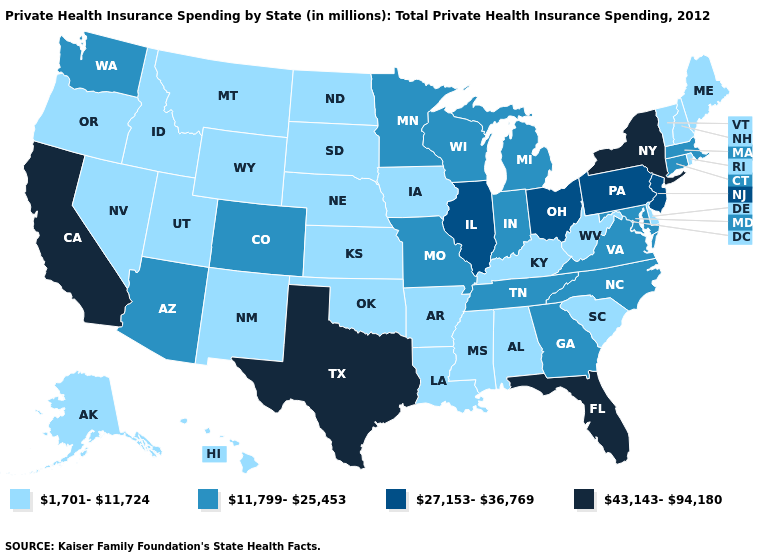Name the states that have a value in the range 1,701-11,724?
Quick response, please. Alabama, Alaska, Arkansas, Delaware, Hawaii, Idaho, Iowa, Kansas, Kentucky, Louisiana, Maine, Mississippi, Montana, Nebraska, Nevada, New Hampshire, New Mexico, North Dakota, Oklahoma, Oregon, Rhode Island, South Carolina, South Dakota, Utah, Vermont, West Virginia, Wyoming. What is the value of North Carolina?
Be succinct. 11,799-25,453. Name the states that have a value in the range 1,701-11,724?
Short answer required. Alabama, Alaska, Arkansas, Delaware, Hawaii, Idaho, Iowa, Kansas, Kentucky, Louisiana, Maine, Mississippi, Montana, Nebraska, Nevada, New Hampshire, New Mexico, North Dakota, Oklahoma, Oregon, Rhode Island, South Carolina, South Dakota, Utah, Vermont, West Virginia, Wyoming. Name the states that have a value in the range 1,701-11,724?
Be succinct. Alabama, Alaska, Arkansas, Delaware, Hawaii, Idaho, Iowa, Kansas, Kentucky, Louisiana, Maine, Mississippi, Montana, Nebraska, Nevada, New Hampshire, New Mexico, North Dakota, Oklahoma, Oregon, Rhode Island, South Carolina, South Dakota, Utah, Vermont, West Virginia, Wyoming. Name the states that have a value in the range 43,143-94,180?
Answer briefly. California, Florida, New York, Texas. What is the highest value in the Northeast ?
Quick response, please. 43,143-94,180. Does Kansas have a lower value than Arizona?
Give a very brief answer. Yes. Among the states that border Mississippi , which have the lowest value?
Quick response, please. Alabama, Arkansas, Louisiana. Among the states that border New York , does New Jersey have the lowest value?
Answer briefly. No. Among the states that border Georgia , which have the lowest value?
Keep it brief. Alabama, South Carolina. Does Nebraska have the lowest value in the MidWest?
Keep it brief. Yes. Does California have the highest value in the USA?
Concise answer only. Yes. Name the states that have a value in the range 1,701-11,724?
Answer briefly. Alabama, Alaska, Arkansas, Delaware, Hawaii, Idaho, Iowa, Kansas, Kentucky, Louisiana, Maine, Mississippi, Montana, Nebraska, Nevada, New Hampshire, New Mexico, North Dakota, Oklahoma, Oregon, Rhode Island, South Carolina, South Dakota, Utah, Vermont, West Virginia, Wyoming. What is the value of North Carolina?
Keep it brief. 11,799-25,453. What is the value of Connecticut?
Write a very short answer. 11,799-25,453. 